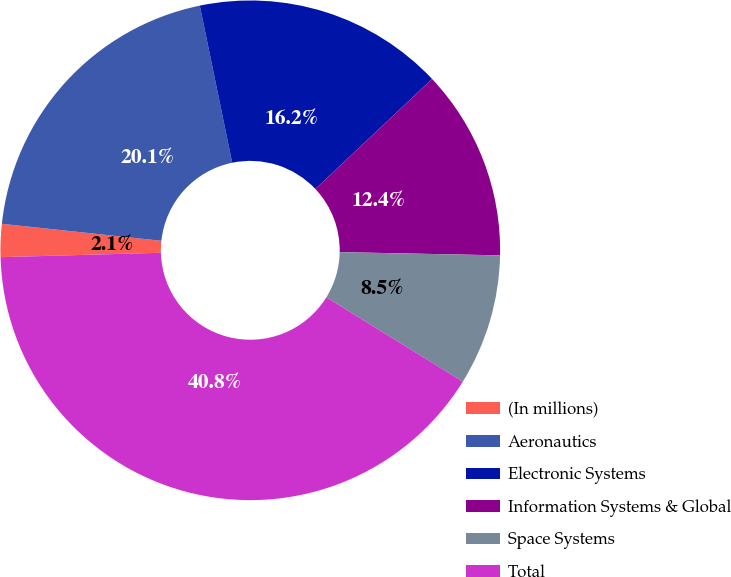Convert chart. <chart><loc_0><loc_0><loc_500><loc_500><pie_chart><fcel>(In millions)<fcel>Aeronautics<fcel>Electronic Systems<fcel>Information Systems & Global<fcel>Space Systems<fcel>Total<nl><fcel>2.13%<fcel>20.07%<fcel>16.21%<fcel>12.35%<fcel>8.49%<fcel>40.75%<nl></chart> 